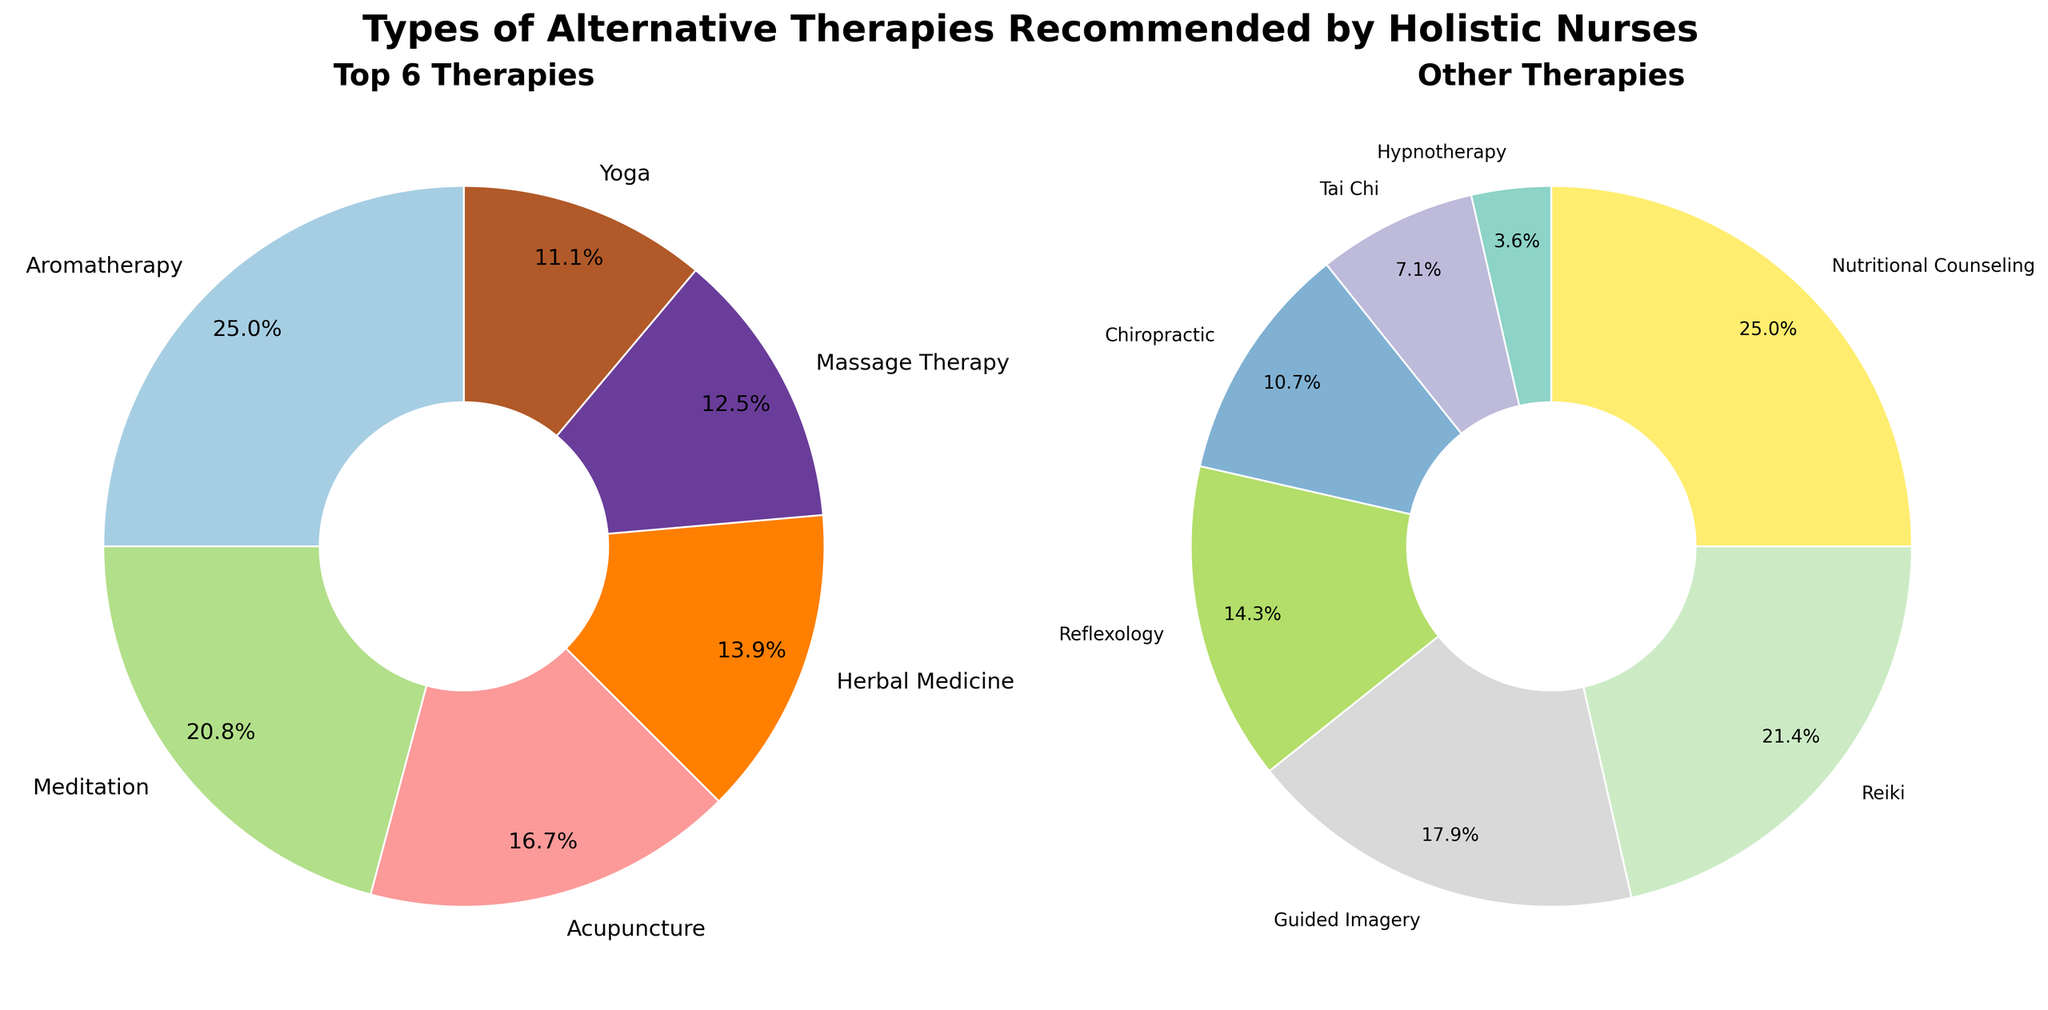What are the two most recommended alternative therapies by holistic nurses? The figure shows a pie chart with the top 6 therapies. The largest sections represent Aromatherapy and Meditation.
Answer: Aromatherapy, Meditation What percentage of recommendations does Herbal Medicine have compared to Acupuncture? Herbal Medicine has 10%, and Acupuncture has 12%. The percentage of recommendations for Herbal Medicine compared to Acupuncture is \( \frac{10}{12} \times 100 \approx 83.3\% \).
Answer: ~83.3% Which therapy is recommended more often: Yoga or Massage Therapy? From the top 6 pie chart, Yoga has 8%, and Massage Therapy has 9%.
Answer: Massage Therapy Add the percentages for Reiki and Reflexology. What is the total? From the other therapies pie chart, Reiki is 6%, and Reflexology is 4%. \( 6 + 4 = 10 \)
Answer: 10% How does the recommendation percentage of Aromatherapy compare to the combined percentage of Yoga and Tai Chi? Aromatherapy is 18%, Yoga is 8%, and Tai Chi is 2%. Combined, Yoga and Tai Chi are \( 8 + 2 = 10 \). Comparing 18% to 10%, Aromatherapy is higher.
Answer: Aromatherapy is higher Which therapy has the smallest recommendation percentage in the figure? From the other therapies pie chart, Hypnotherapy has the smallest percentage at 1%.
Answer: Hypnotherapy What is the combined percentage of Acupuncture, Nutritional Counseling, and Chiropractic? Acupuncture is 12%, Nutritional Counseling is 7%, and Chiropractic is 3%. \( 12 + 7 + 3 = 22 \)
Answer: 22% Are there more therapies recommended higher than 10% or less than 5%? Higher than 10%: Aromatherapy (18%), Meditation (15%), Acupuncture (12%)—3 therapies. Less than 5%: Reflexology (4%), Chiropractic (3%), Tai Chi (2%), Hypnotherapy (1%)—4 therapies.
Answer: Less than 5% What is the average percentage of the top three recommended therapies? The top three are Aromatherapy (18%), Meditation (15%), and Acupuncture (12%). The average is \( \frac{18 + 15 + 12}{3} = \frac{45}{3} = 15 \)
Answer: 15 